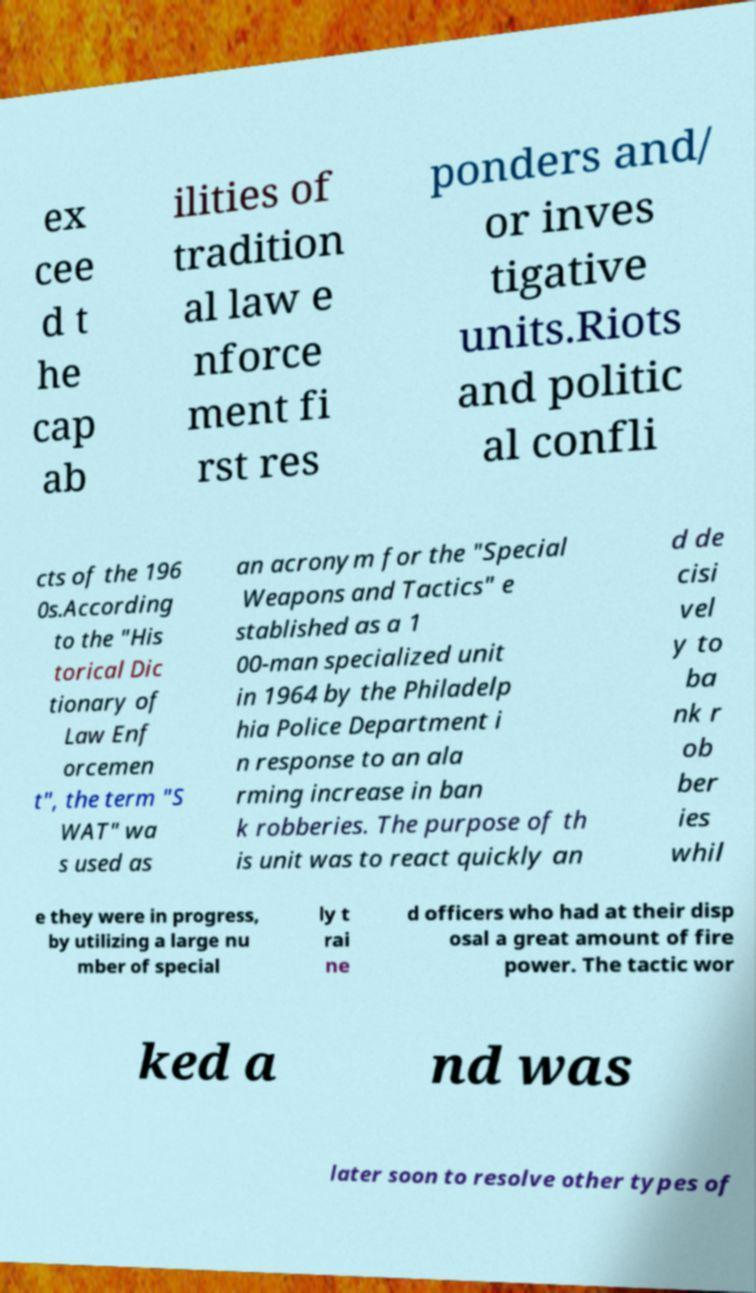Please read and relay the text visible in this image. What does it say? ex cee d t he cap ab ilities of tradition al law e nforce ment fi rst res ponders and/ or inves tigative units.Riots and politic al confli cts of the 196 0s.According to the "His torical Dic tionary of Law Enf orcemen t", the term "S WAT" wa s used as an acronym for the "Special Weapons and Tactics" e stablished as a 1 00-man specialized unit in 1964 by the Philadelp hia Police Department i n response to an ala rming increase in ban k robberies. The purpose of th is unit was to react quickly an d de cisi vel y to ba nk r ob ber ies whil e they were in progress, by utilizing a large nu mber of special ly t rai ne d officers who had at their disp osal a great amount of fire power. The tactic wor ked a nd was later soon to resolve other types of 